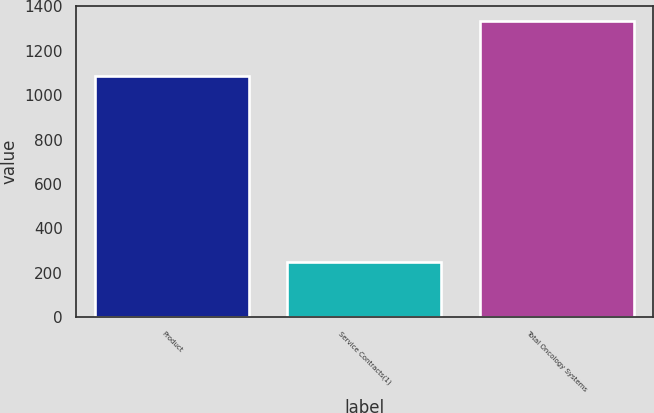Convert chart. <chart><loc_0><loc_0><loc_500><loc_500><bar_chart><fcel>Product<fcel>Service Contracts(1)<fcel>Total Oncology Systems<nl><fcel>1088<fcel>248<fcel>1336<nl></chart> 